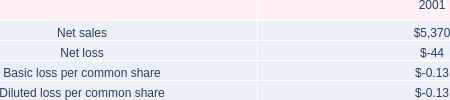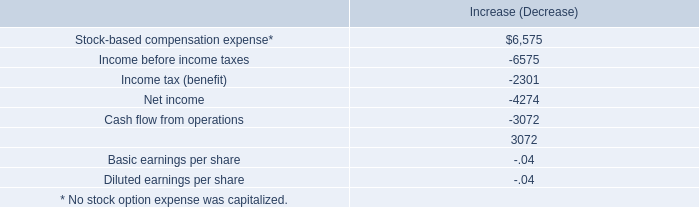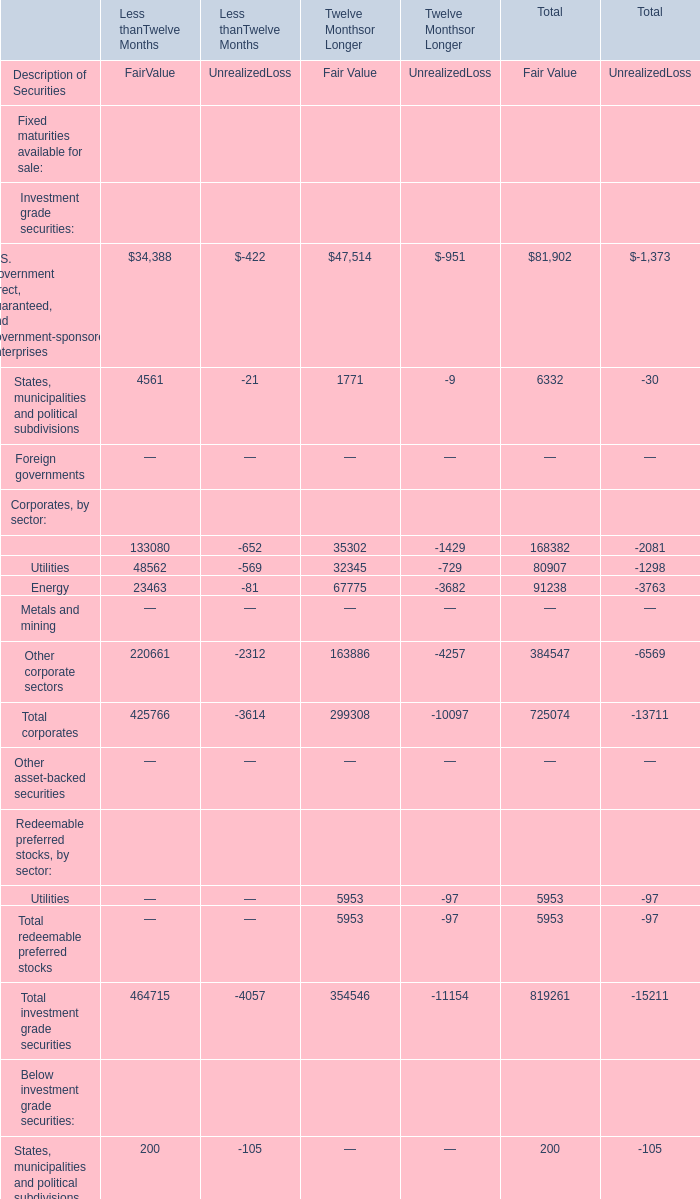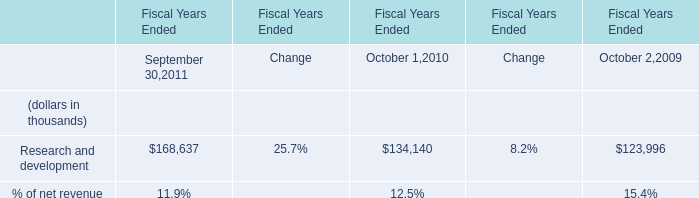What's the sum of all FairValue that are greater than 100000 in Less thanTwelve Months? 
Computations: (133080 + 220661)
Answer: 353741.0. 